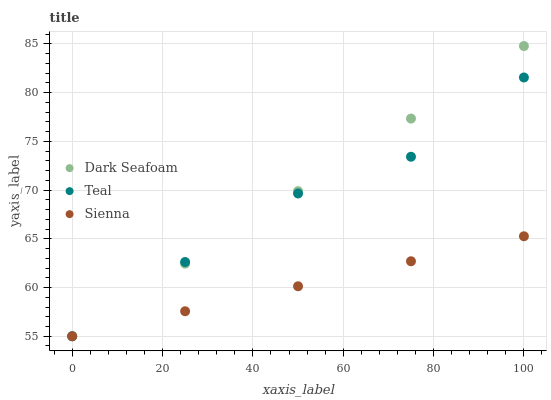Does Sienna have the minimum area under the curve?
Answer yes or no. Yes. Does Dark Seafoam have the maximum area under the curve?
Answer yes or no. Yes. Does Teal have the minimum area under the curve?
Answer yes or no. No. Does Teal have the maximum area under the curve?
Answer yes or no. No. Is Dark Seafoam the smoothest?
Answer yes or no. Yes. Is Teal the roughest?
Answer yes or no. Yes. Is Teal the smoothest?
Answer yes or no. No. Is Dark Seafoam the roughest?
Answer yes or no. No. Does Sienna have the lowest value?
Answer yes or no. Yes. Does Dark Seafoam have the highest value?
Answer yes or no. Yes. Does Teal have the highest value?
Answer yes or no. No. Does Teal intersect Sienna?
Answer yes or no. Yes. Is Teal less than Sienna?
Answer yes or no. No. Is Teal greater than Sienna?
Answer yes or no. No. 